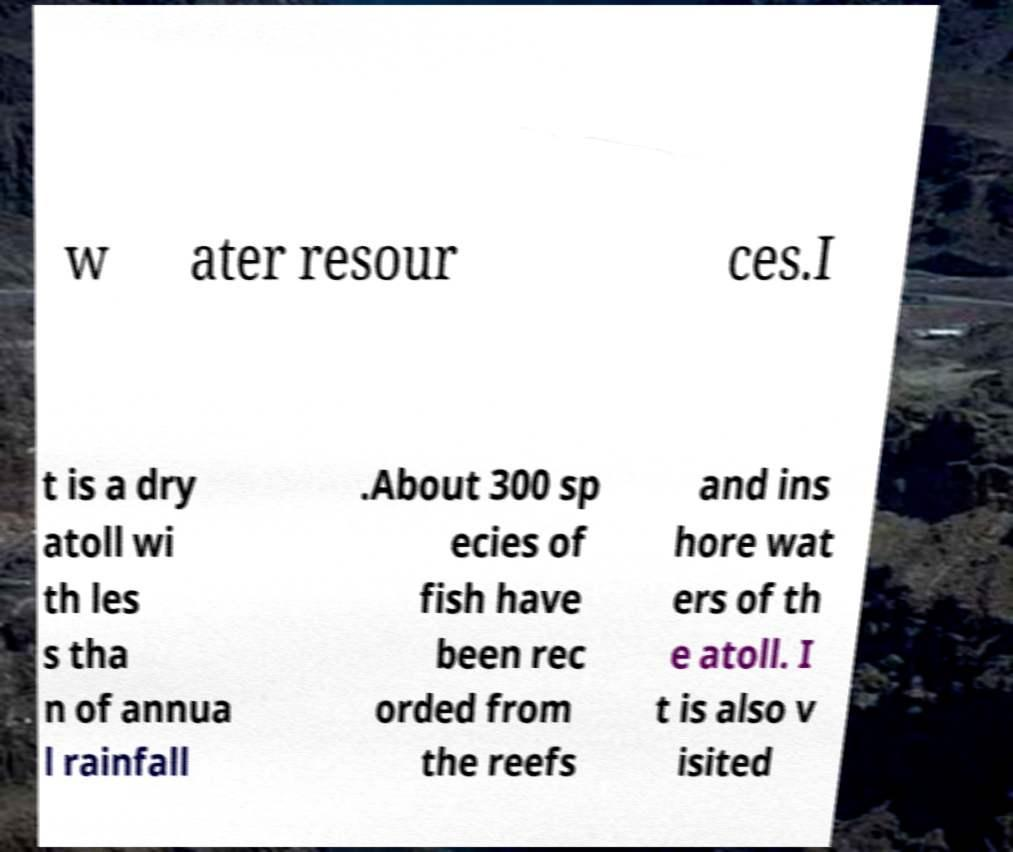Please read and relay the text visible in this image. What does it say? w ater resour ces.I t is a dry atoll wi th les s tha n of annua l rainfall .About 300 sp ecies of fish have been rec orded from the reefs and ins hore wat ers of th e atoll. I t is also v isited 